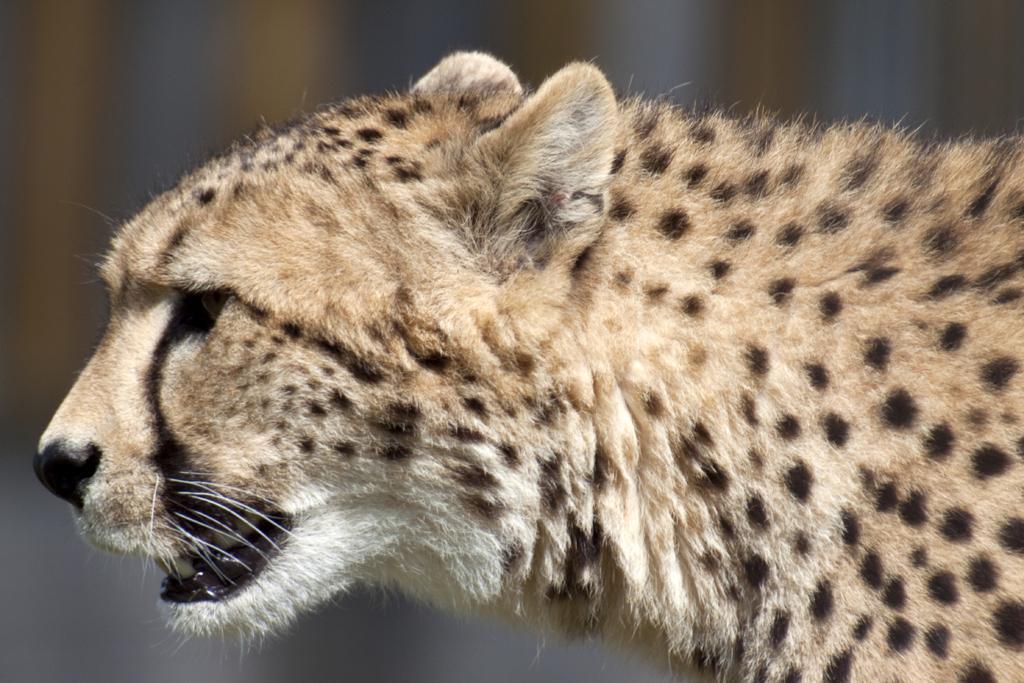How would you summarize this image in a sentence or two? Background portion of the picture is blur. In this picture we can see a cheetah. 